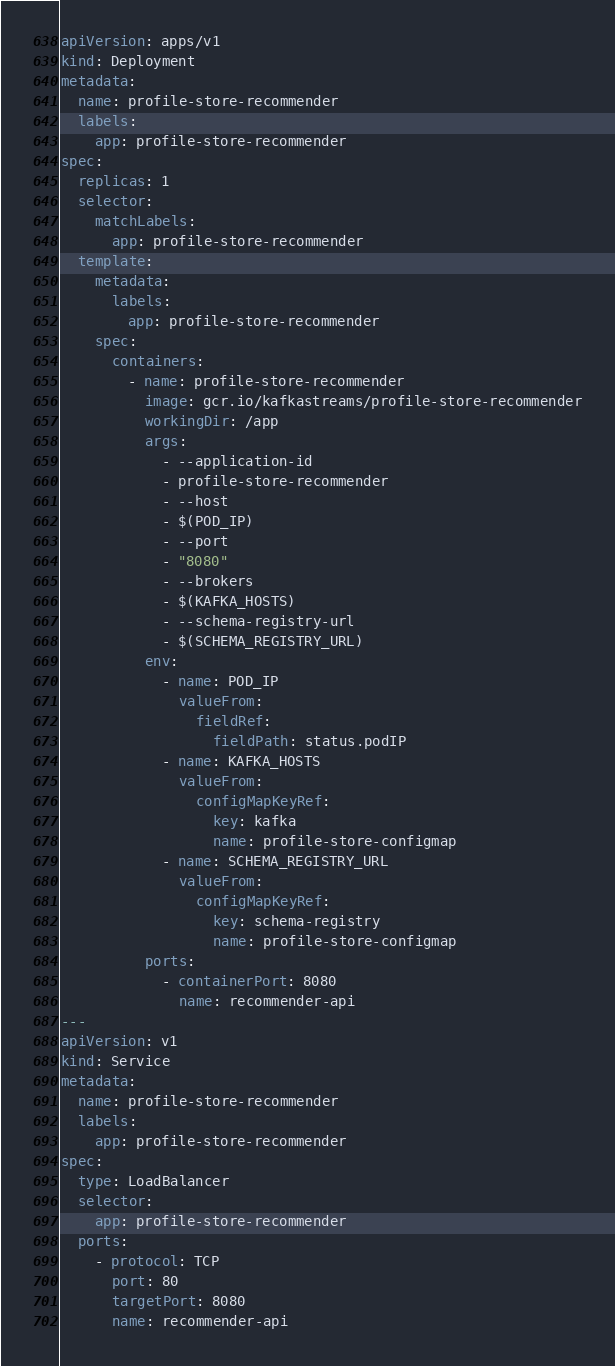<code> <loc_0><loc_0><loc_500><loc_500><_YAML_>apiVersion: apps/v1
kind: Deployment
metadata:
  name: profile-store-recommender
  labels:
    app: profile-store-recommender
spec:
  replicas: 1
  selector:
    matchLabels:
      app: profile-store-recommender
  template:
    metadata:
      labels:
        app: profile-store-recommender
    spec:
      containers:
        - name: profile-store-recommender
          image: gcr.io/kafkastreams/profile-store-recommender
          workingDir: /app
          args:
            - --application-id
            - profile-store-recommender
            - --host
            - $(POD_IP)
            - --port
            - "8080"
            - --brokers
            - $(KAFKA_HOSTS)
            - --schema-registry-url
            - $(SCHEMA_REGISTRY_URL)
          env:
            - name: POD_IP
              valueFrom:
                fieldRef:
                  fieldPath: status.podIP
            - name: KAFKA_HOSTS
              valueFrom:
                configMapKeyRef:
                  key: kafka
                  name: profile-store-configmap
            - name: SCHEMA_REGISTRY_URL
              valueFrom:
                configMapKeyRef:
                  key: schema-registry
                  name: profile-store-configmap
          ports:
            - containerPort: 8080
              name: recommender-api
---
apiVersion: v1
kind: Service
metadata:
  name: profile-store-recommender
  labels:
    app: profile-store-recommender
spec:
  type: LoadBalancer
  selector:
    app: profile-store-recommender
  ports:
    - protocol: TCP
      port: 80
      targetPort: 8080
      name: recommender-api</code> 